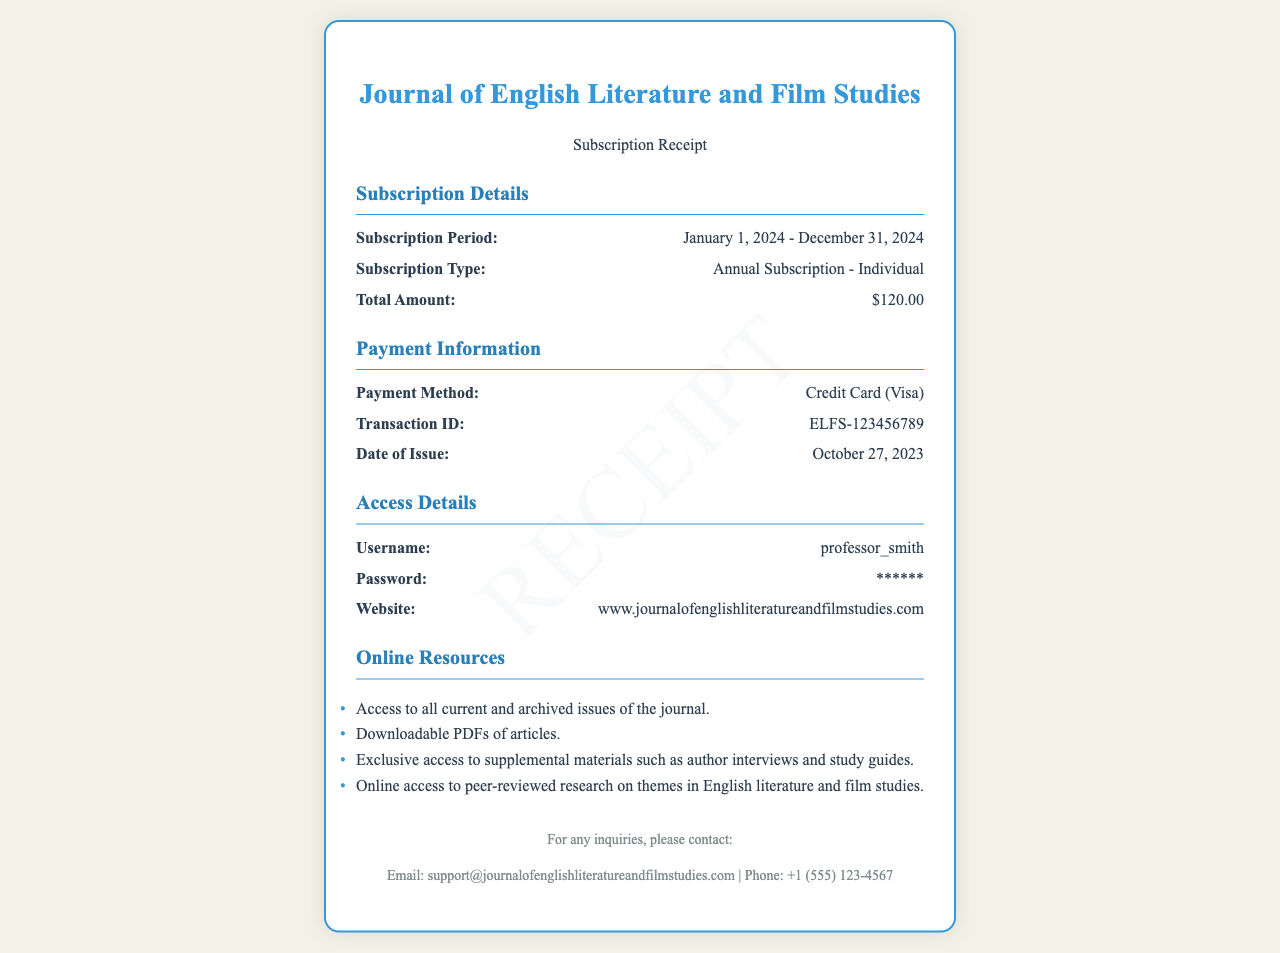what is the subscription period? The subscription period is clearly stated in the document, from January 1, 2024, to December 31, 2024.
Answer: January 1, 2024 - December 31, 2024 what is the total amount paid? The total amount is listed under Subscription Details, which amounts to $120.00.
Answer: $120.00 what payment method was used? The payment method is mentioned under Payment Information as Credit Card (Visa).
Answer: Credit Card (Visa) what is the transaction ID? The transaction ID is provided in the Payment Information section as ELFS-123456789.
Answer: ELFS-123456789 who is the username associated with the subscription? The username is detailed in the Access Details section, specified as professor_smith.
Answer: professor_smith what is the website for online access? The website link is included in the Access Details section, which is www.journalofenglishliteratureandfilmstudies.com.
Answer: www.journalofenglishliteratureandfilmstudies.com what type of subscription is this? The subscription type is referenced in the Subscription Details as Annual Subscription - Individual.
Answer: Annual Subscription - Individual which resources are accessible online? Online resources are listed and include access to all current and archived issues, downloadable PDFs, exclusive materials, and peer-reviewed research.
Answer: all current and archived issues of the journal, downloadable PDFs of articles, exclusive access to supplemental materials, online access to peer-reviewed research when was the receipt issued? The date of issue is mentioned in Payment Information as October 27, 2023.
Answer: October 27, 2023 